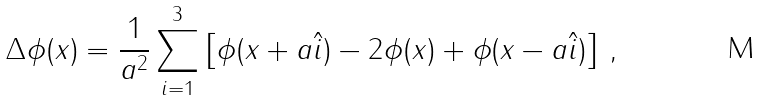Convert formula to latex. <formula><loc_0><loc_0><loc_500><loc_500>\Delta \phi ( x ) = \frac { 1 } { a ^ { 2 } } \sum ^ { 3 } _ { i = 1 } \left [ \phi ( x + a \hat { i } ) - 2 \phi ( x ) + \phi ( x - a \hat { i } ) \right ] \, ,</formula> 